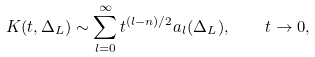Convert formula to latex. <formula><loc_0><loc_0><loc_500><loc_500>K ( t , \Delta _ { L } ) \sim \sum _ { l = 0 } ^ { \infty } t ^ { ( l - n ) / 2 } a _ { l } ( \Delta _ { L } ) , \quad t \to 0 ,</formula> 